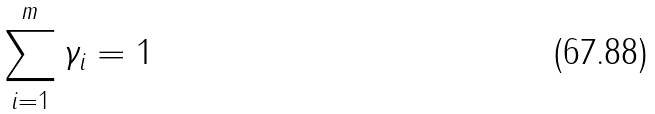<formula> <loc_0><loc_0><loc_500><loc_500>\sum _ { i = 1 } ^ { m } \gamma _ { i } = 1</formula> 